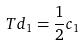Convert formula to latex. <formula><loc_0><loc_0><loc_500><loc_500>T d _ { 1 } = \frac { 1 } { 2 } c _ { 1 }</formula> 